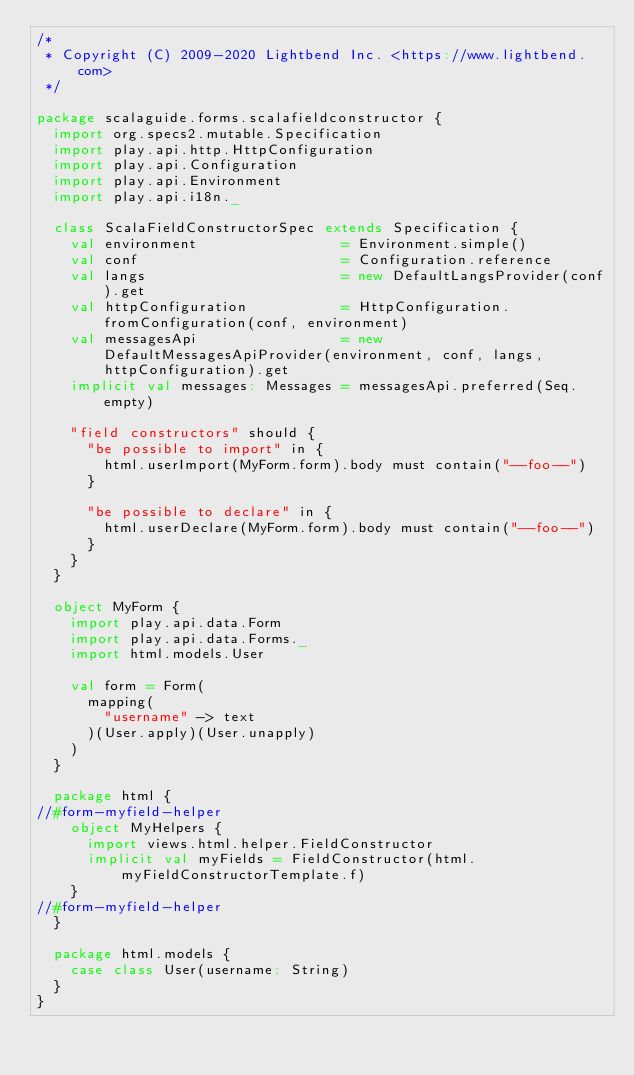Convert code to text. <code><loc_0><loc_0><loc_500><loc_500><_Scala_>/*
 * Copyright (C) 2009-2020 Lightbend Inc. <https://www.lightbend.com>
 */

package scalaguide.forms.scalafieldconstructor {
  import org.specs2.mutable.Specification
  import play.api.http.HttpConfiguration
  import play.api.Configuration
  import play.api.Environment
  import play.api.i18n._

  class ScalaFieldConstructorSpec extends Specification {
    val environment                 = Environment.simple()
    val conf                        = Configuration.reference
    val langs                       = new DefaultLangsProvider(conf).get
    val httpConfiguration           = HttpConfiguration.fromConfiguration(conf, environment)
    val messagesApi                 = new DefaultMessagesApiProvider(environment, conf, langs, httpConfiguration).get
    implicit val messages: Messages = messagesApi.preferred(Seq.empty)

    "field constructors" should {
      "be possible to import" in {
        html.userImport(MyForm.form).body must contain("--foo--")
      }

      "be possible to declare" in {
        html.userDeclare(MyForm.form).body must contain("--foo--")
      }
    }
  }

  object MyForm {
    import play.api.data.Form
    import play.api.data.Forms._
    import html.models.User

    val form = Form(
      mapping(
        "username" -> text
      )(User.apply)(User.unapply)
    )
  }

  package html {
//#form-myfield-helper
    object MyHelpers {
      import views.html.helper.FieldConstructor
      implicit val myFields = FieldConstructor(html.myFieldConstructorTemplate.f)
    }
//#form-myfield-helper
  }

  package html.models {
    case class User(username: String)
  }
}
</code> 